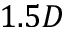<formula> <loc_0><loc_0><loc_500><loc_500>1 . 5 D</formula> 